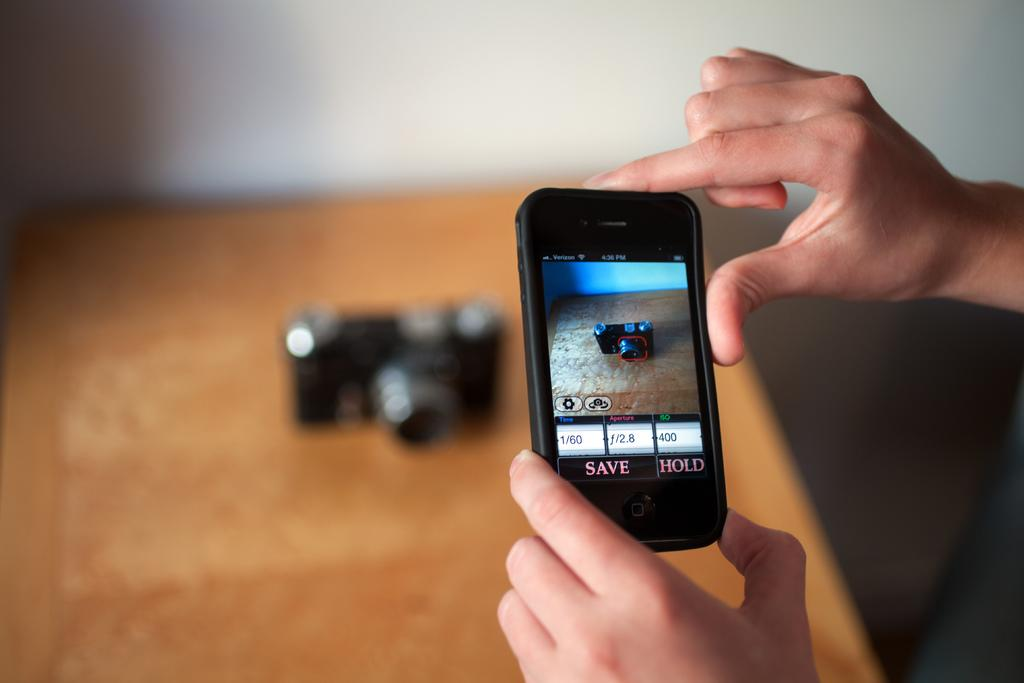<image>
Give a short and clear explanation of the subsequent image. a phone with the word save at the bottom of it 